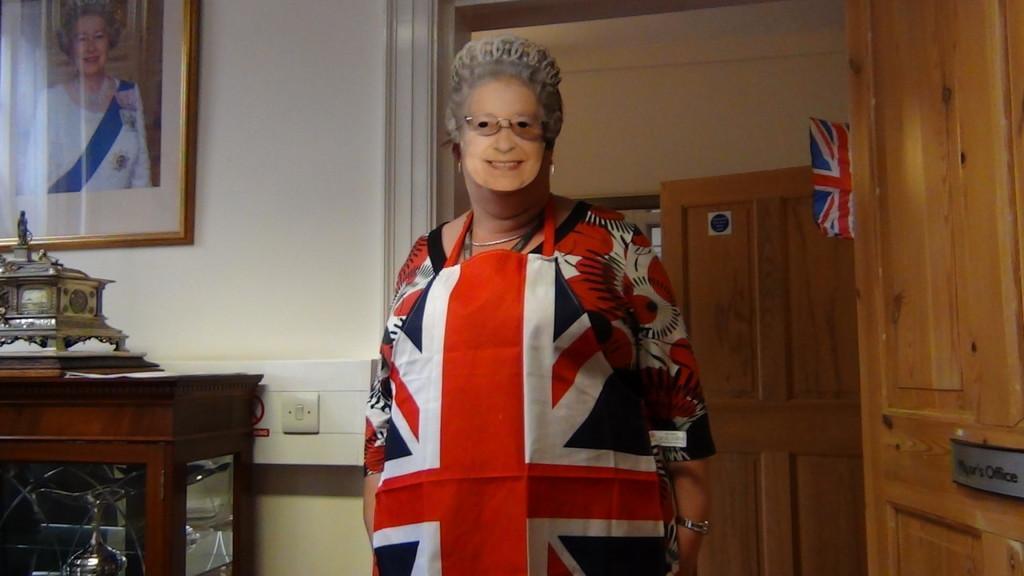Please provide a concise description of this image. In this picture we can see a woman standing with a mask on her face. 